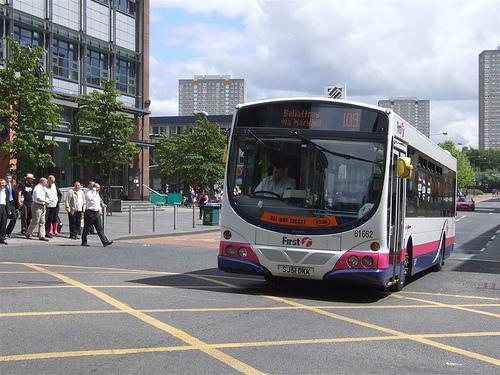Question: when was the image taken?
Choices:
A. Nighttime.
B. Before sunrise.
C. After sunset.
D. Daytime.
Answer with the letter. Answer: D 